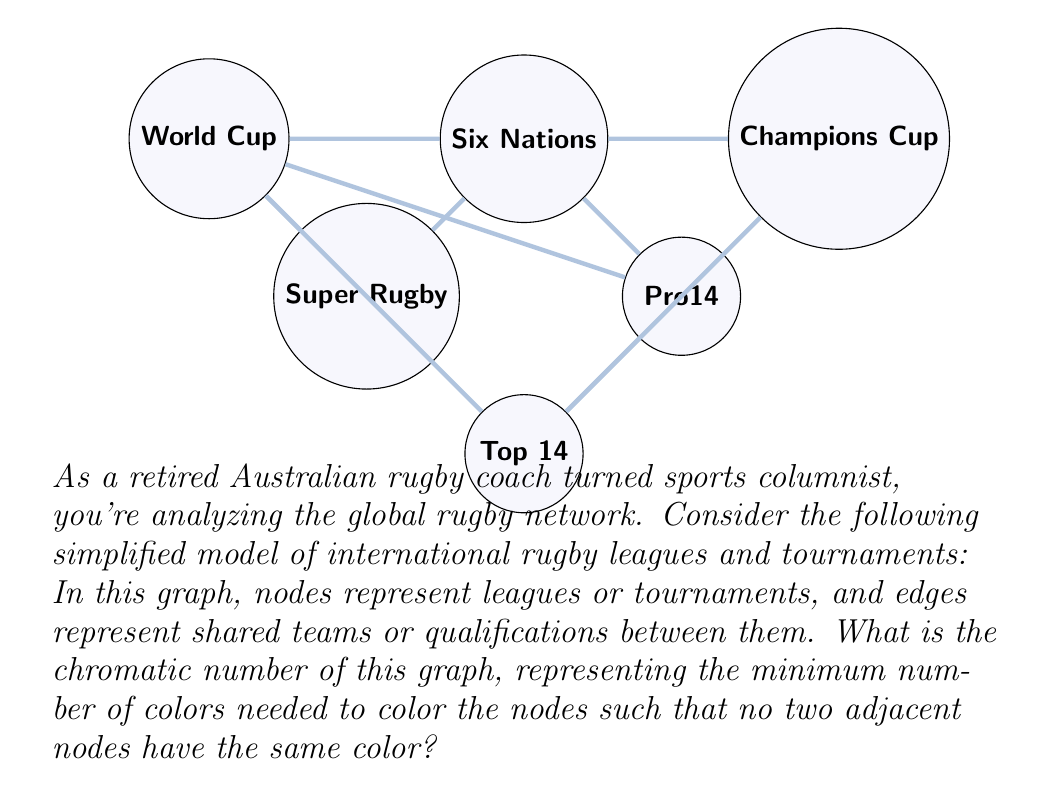Could you help me with this problem? To find the chromatic number, we'll use a greedy coloring algorithm and analyze the graph structure:

1) Start with Super Rugby (SR). Assign it color 1.

2) Six Nations (6N) is connected to SR, so it needs a different color. Assign color 2.

3) Pro14 is connected to 6N but not SR. It can use color 1.

4) Top 14 is connected to SR and Pro14. It needs a new color: 3.

5) World Cup is connected to SR, 6N, and Pro14. It needs a new color: 4.

6) Champions Cup is connected to 6N and Top 14. It can use color 1.

Verify no adjacent nodes have the same color:
- Color 1: SR, Pro14, Champions Cup (not connected)
- Color 2: Six Nations
- Color 3: Top 14
- Color 4: World Cup

We used 4 colors, and it's impossible to use fewer because the World Cup is connected to nodes of 3 different colors.

The chromatic number $\chi(G)$ is thus 4.

This coloring represents how tournaments could be scheduled without conflicts, which is relevant for a sports columnist analyzing the global rugby structure.
Answer: $\chi(G) = 4$ 